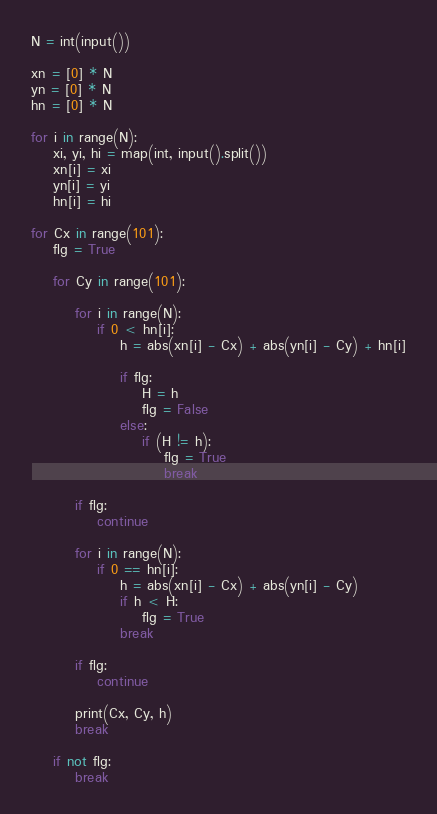<code> <loc_0><loc_0><loc_500><loc_500><_Python_>N = int(input())

xn = [0] * N
yn = [0] * N
hn = [0] * N

for i in range(N):
    xi, yi, hi = map(int, input().split())
    xn[i] = xi
    yn[i] = yi
    hn[i] = hi

for Cx in range(101):
    flg = True

    for Cy in range(101):

        for i in range(N):
            if 0 < hn[i]:
                h = abs(xn[i] - Cx) + abs(yn[i] - Cy) + hn[i]

                if flg:
                    H = h
                    flg = False
                else:
                    if (H != h):
                        flg = True
                        break

        if flg:
            continue

        for i in range(N):
            if 0 == hn[i]:
                h = abs(xn[i] - Cx) + abs(yn[i] - Cy)
                if h < H:
                    flg = True
                break

        if flg:
            continue

        print(Cx, Cy, h)
        break

    if not flg:
        break
</code> 